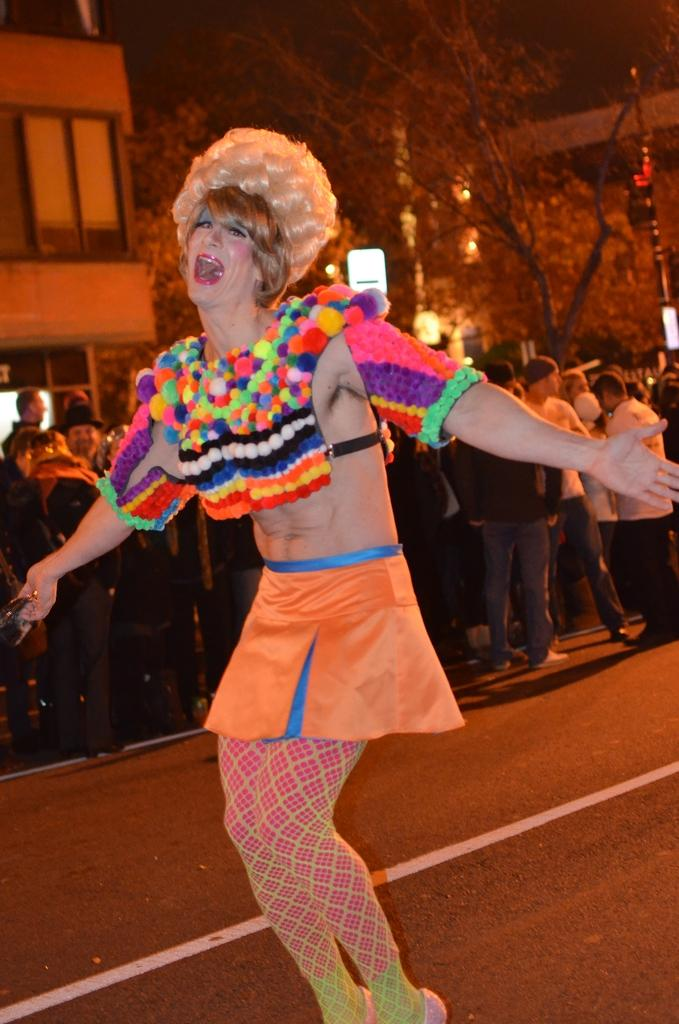What is the main subject of the image? There is a man on the road in the image. Can you describe the background of the image? There are people standing in the background of the image, along with trees and buildings. What type of appliance can be seen in the man's hand in the image? There is no appliance visible in the man's hand in the image. 